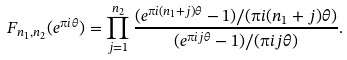<formula> <loc_0><loc_0><loc_500><loc_500>F _ { n _ { 1 } , n _ { 2 } } ( e ^ { \i i \theta } ) = \prod _ { j = 1 } ^ { n _ { 2 } } \frac { ( e ^ { \i i ( n _ { 1 } + j ) \theta } - 1 ) / ( \i i ( n _ { 1 } + j ) \theta ) } { ( e ^ { \i i j \theta } - 1 ) / ( \i i j \theta ) } .</formula> 